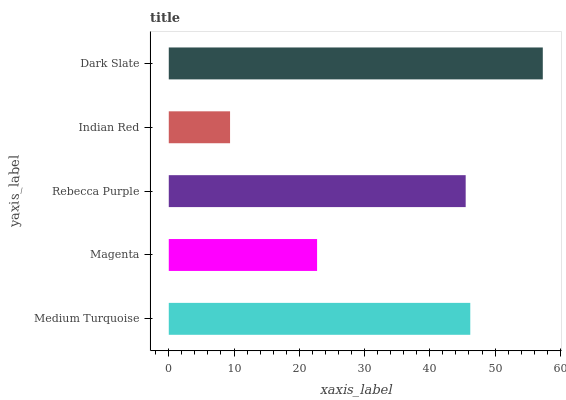Is Indian Red the minimum?
Answer yes or no. Yes. Is Dark Slate the maximum?
Answer yes or no. Yes. Is Magenta the minimum?
Answer yes or no. No. Is Magenta the maximum?
Answer yes or no. No. Is Medium Turquoise greater than Magenta?
Answer yes or no. Yes. Is Magenta less than Medium Turquoise?
Answer yes or no. Yes. Is Magenta greater than Medium Turquoise?
Answer yes or no. No. Is Medium Turquoise less than Magenta?
Answer yes or no. No. Is Rebecca Purple the high median?
Answer yes or no. Yes. Is Rebecca Purple the low median?
Answer yes or no. Yes. Is Magenta the high median?
Answer yes or no. No. Is Indian Red the low median?
Answer yes or no. No. 